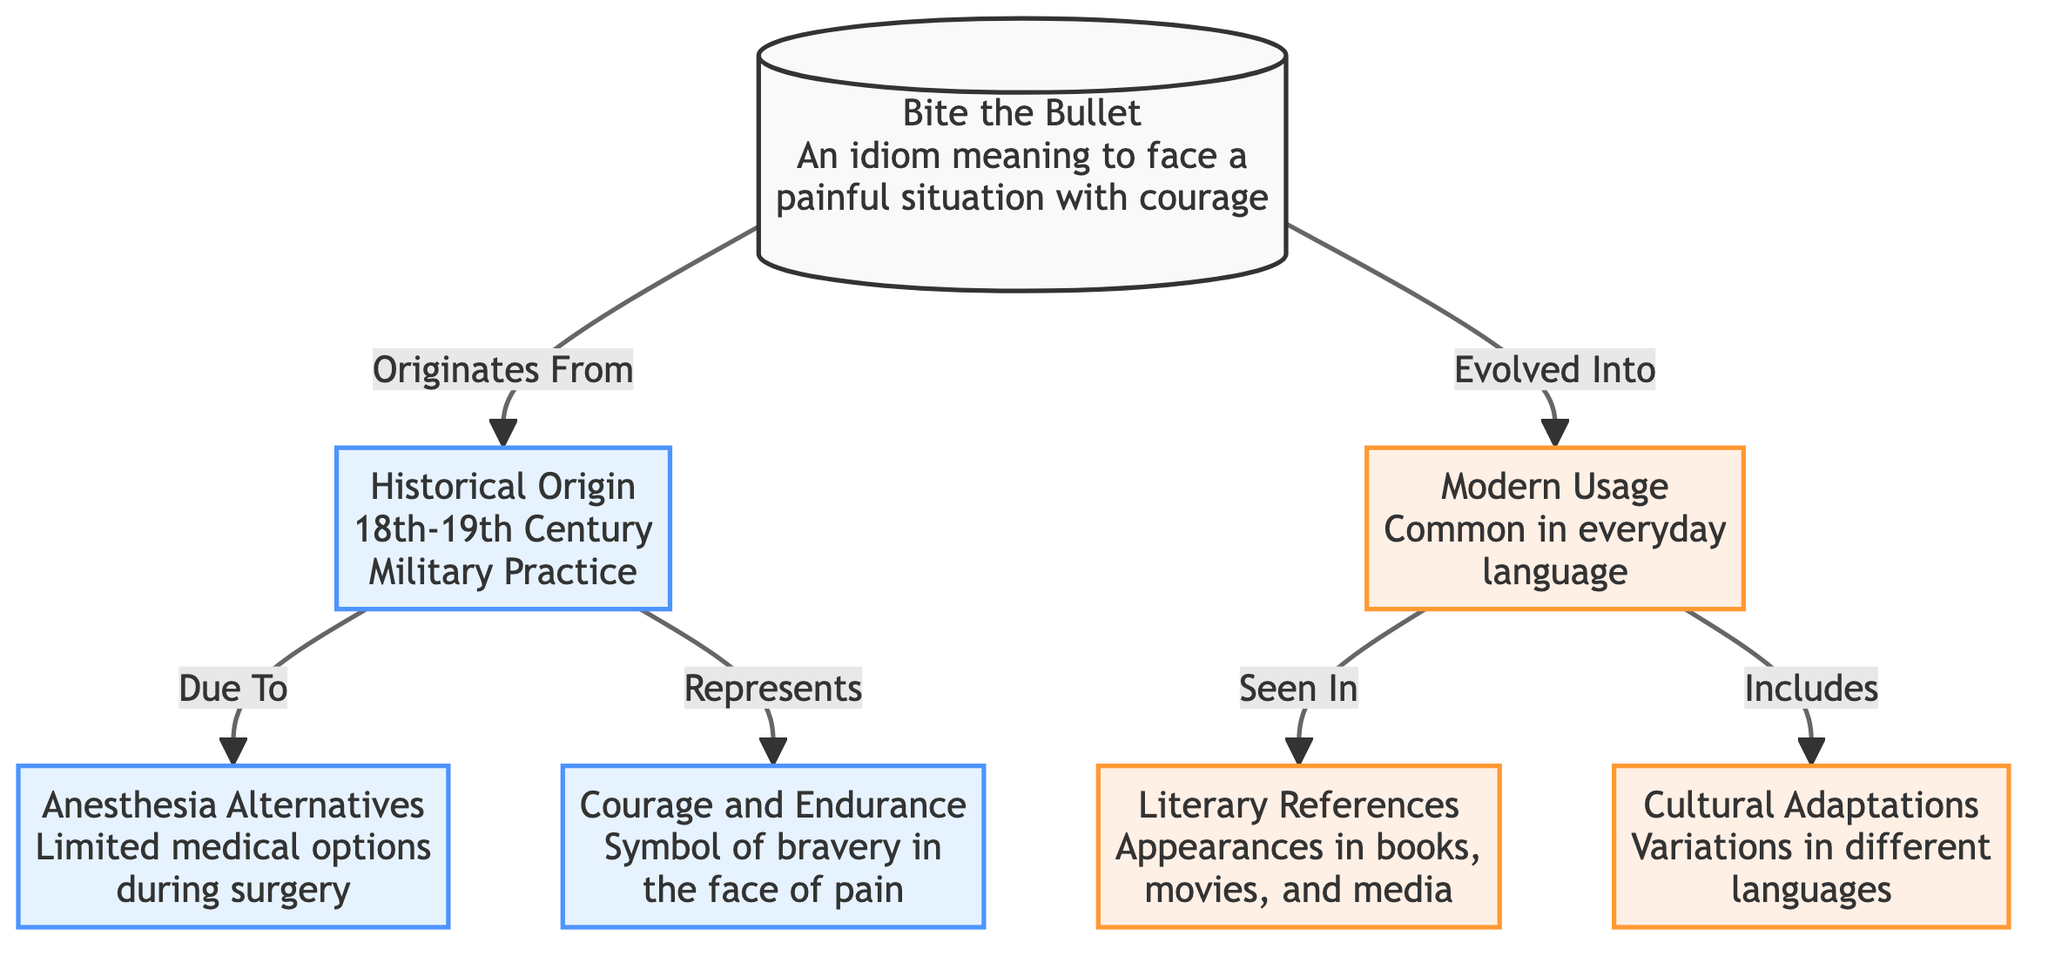What is the meaning of "Bite the Bullet"? The diagram states that it means to face a painful situation with courage, which is directly described in the first node labeled "Bite the Bullet".
Answer: face a painful situation with courage What century does the historical origin of "Bite the Bullet" belong to? In the diagram, the second node labeled "Historical Origin" specifies the 18th-19th Century, indicating when the idiom originated.
Answer: 18th-19th Century How many nodes are related to modern usage? The diagram shows three nodes linked to modern usage: "Common in everyday language", "Appearances in books, movies, and media", and "Variations in different languages". Counting these yields three nodes.
Answer: 3 What does the historical origin node represent? The diagram indicates that the historical origin node represents "Courage and Endurance", which is explicitly mentioned as characteristic of the origin.
Answer: Courage and Endurance What alternatives to anesthesia are mentioned in the diagram? The diagram identifies "Limited medical options during surgery" as the context under which the "Bite the Bullet" idiom arose, suggesting that it served as a reaction to alternatives.
Answer: Limited medical options What relationship exists between "Historical Origin" and "Courage and Endurance"? The diagram shows a directed link labeled "Represents," indicating that the historical origin of "Bite the Bullet" symbolizes courage and endurance in the face of pain.
Answer: Represents How does the idiom's meaning evolve into modern usage? The diagram shows a directed connection from the node "Bite the Bullet" to "Modern Usage," labeled "Evolved Into," which demonstrates the transition in its application.
Answer: Evolved Into What aspect of modern usage relates to literature? The diagram specifies that modern usage includes "Literary References" as a category, which indicates that the idiom appears in various literary works.
Answer: Literary References What does "Cultural Adaptations" refer to in the context of the diagram? The diagram categorizes "Cultural Adaptations" as variations of the idiom in different languages, illustrating its diversity across cultures.
Answer: Variations in different languages 